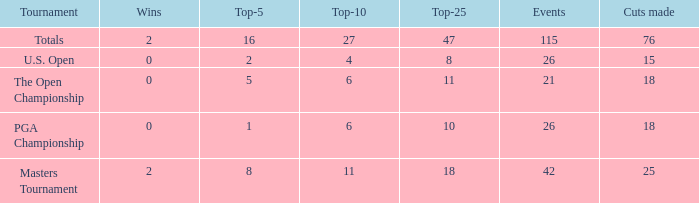Could you help me parse every detail presented in this table? {'header': ['Tournament', 'Wins', 'Top-5', 'Top-10', 'Top-25', 'Events', 'Cuts made'], 'rows': [['Totals', '2', '16', '27', '47', '115', '76'], ['U.S. Open', '0', '2', '4', '8', '26', '15'], ['The Open Championship', '0', '5', '6', '11', '21', '18'], ['PGA Championship', '0', '1', '6', '10', '26', '18'], ['Masters Tournament', '2', '8', '11', '18', '42', '25']]} What is the average Top-10 with a greater than 11 Top-25 and a less than 2 wins? None. 